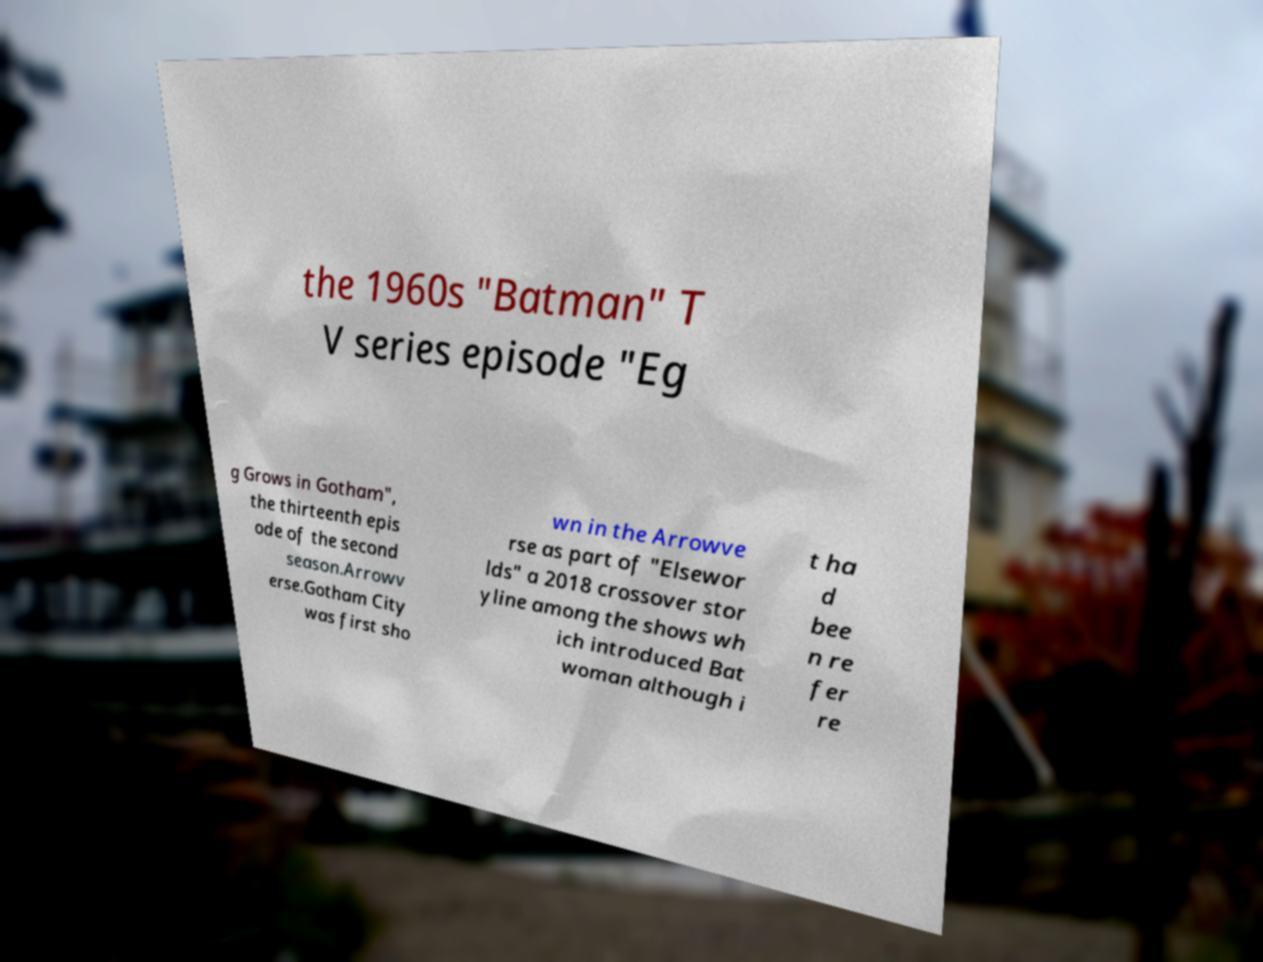Please read and relay the text visible in this image. What does it say? the 1960s "Batman" T V series episode "Eg g Grows in Gotham", the thirteenth epis ode of the second season.Arrowv erse.Gotham City was first sho wn in the Arrowve rse as part of "Elsewor lds" a 2018 crossover stor yline among the shows wh ich introduced Bat woman although i t ha d bee n re fer re 